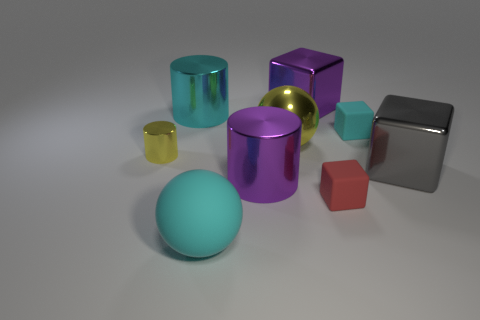Subtract all big cylinders. How many cylinders are left? 1 Subtract all purple cubes. How many cubes are left? 3 Subtract 1 cylinders. How many cylinders are left? 2 Subtract all spheres. How many objects are left? 7 Subtract all gray blocks. Subtract all yellow cylinders. How many blocks are left? 3 Add 7 purple objects. How many purple objects exist? 9 Subtract 0 brown cylinders. How many objects are left? 9 Subtract all big brown things. Subtract all tiny red cubes. How many objects are left? 8 Add 9 yellow metal cylinders. How many yellow metal cylinders are left? 10 